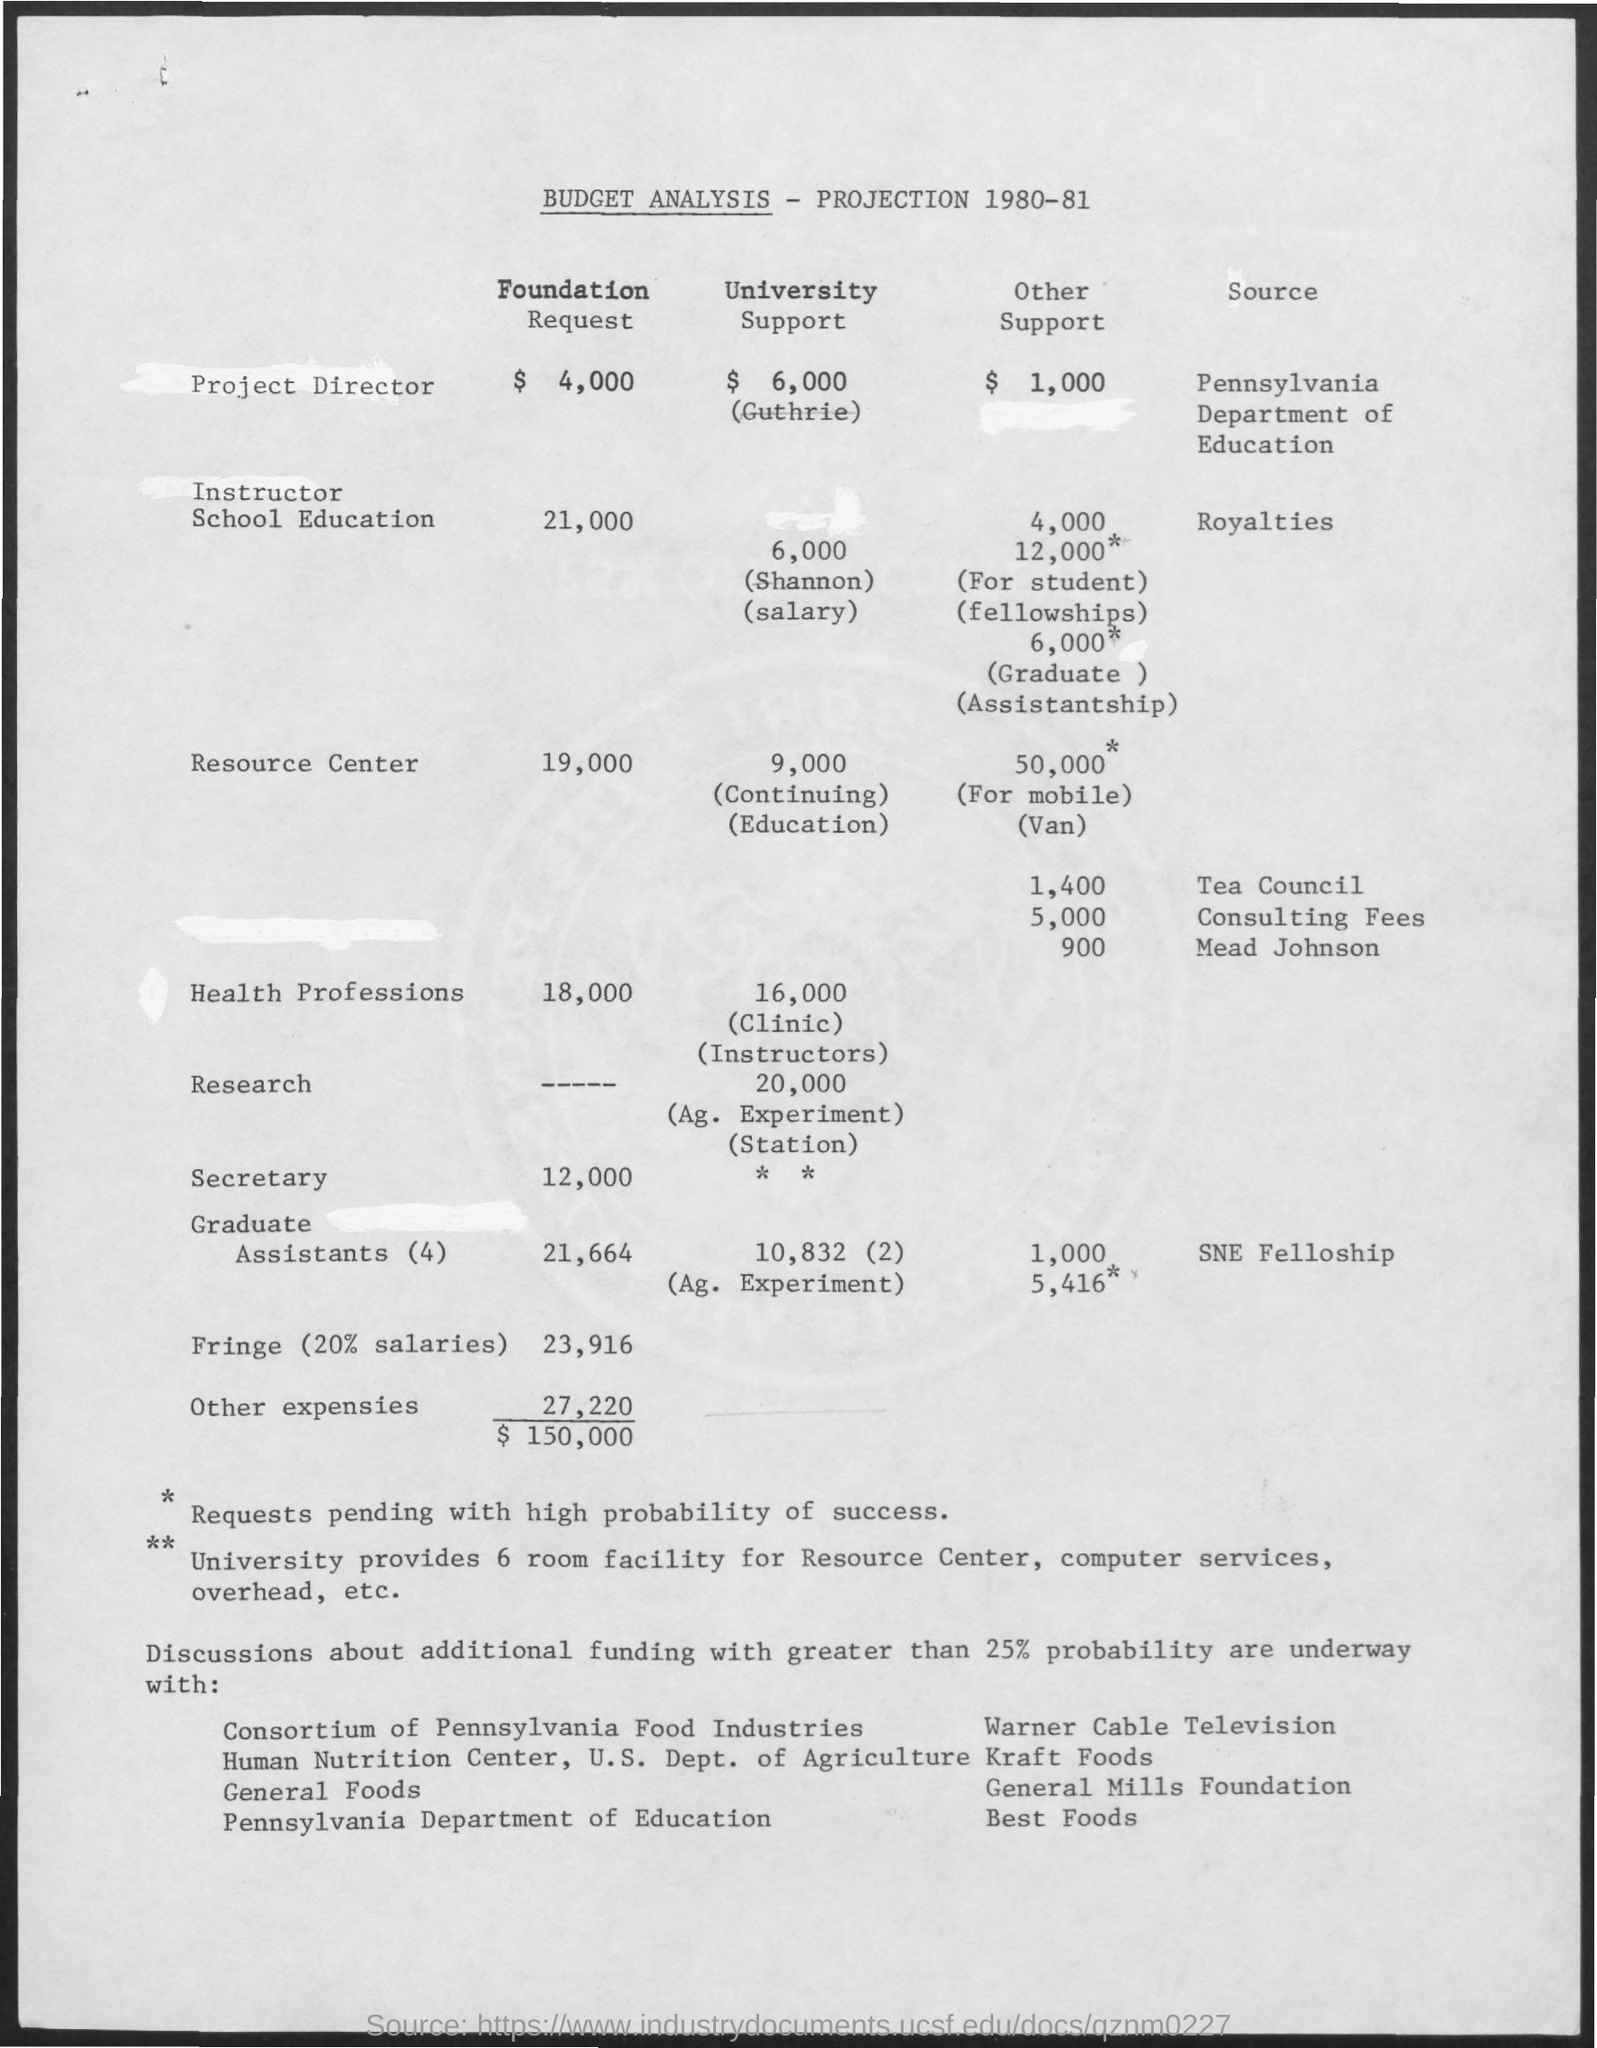What is the amount for project director in foundation request ?
Provide a short and direct response. $ 4,000. What is the amount for instructor school education in university support?
Offer a terse response. $ 6,000. What is the amount mentioned for health professions in foundation request ?
Your response must be concise. 18,000. What is the amount mentioned for resource center in foundation request ?
Make the answer very short. 19,000. What is the amount mentioned for secretary in foundation request ?
Ensure brevity in your answer.  12,000. 